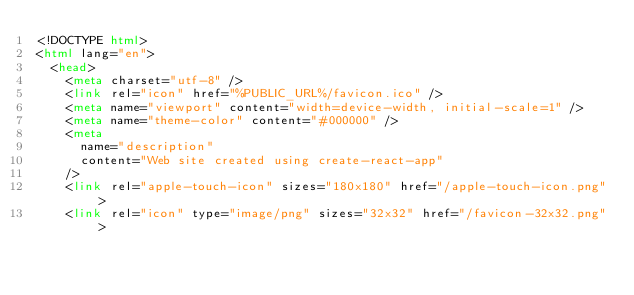Convert code to text. <code><loc_0><loc_0><loc_500><loc_500><_HTML_><!DOCTYPE html>
<html lang="en">
  <head>
    <meta charset="utf-8" />
    <link rel="icon" href="%PUBLIC_URL%/favicon.ico" />
    <meta name="viewport" content="width=device-width, initial-scale=1" />
    <meta name="theme-color" content="#000000" />
    <meta
      name="description"
      content="Web site created using create-react-app"
    />
    <link rel="apple-touch-icon" sizes="180x180" href="/apple-touch-icon.png">
    <link rel="icon" type="image/png" sizes="32x32" href="/favicon-32x32.png"></code> 